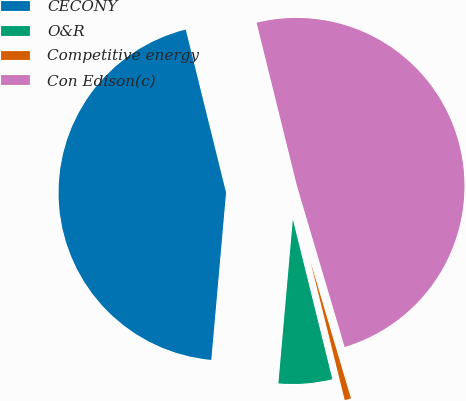Convert chart to OTSL. <chart><loc_0><loc_0><loc_500><loc_500><pie_chart><fcel>CECONY<fcel>O&R<fcel>Competitive energy<fcel>Con Edison(c)<nl><fcel>44.74%<fcel>5.26%<fcel>0.72%<fcel>49.28%<nl></chart> 